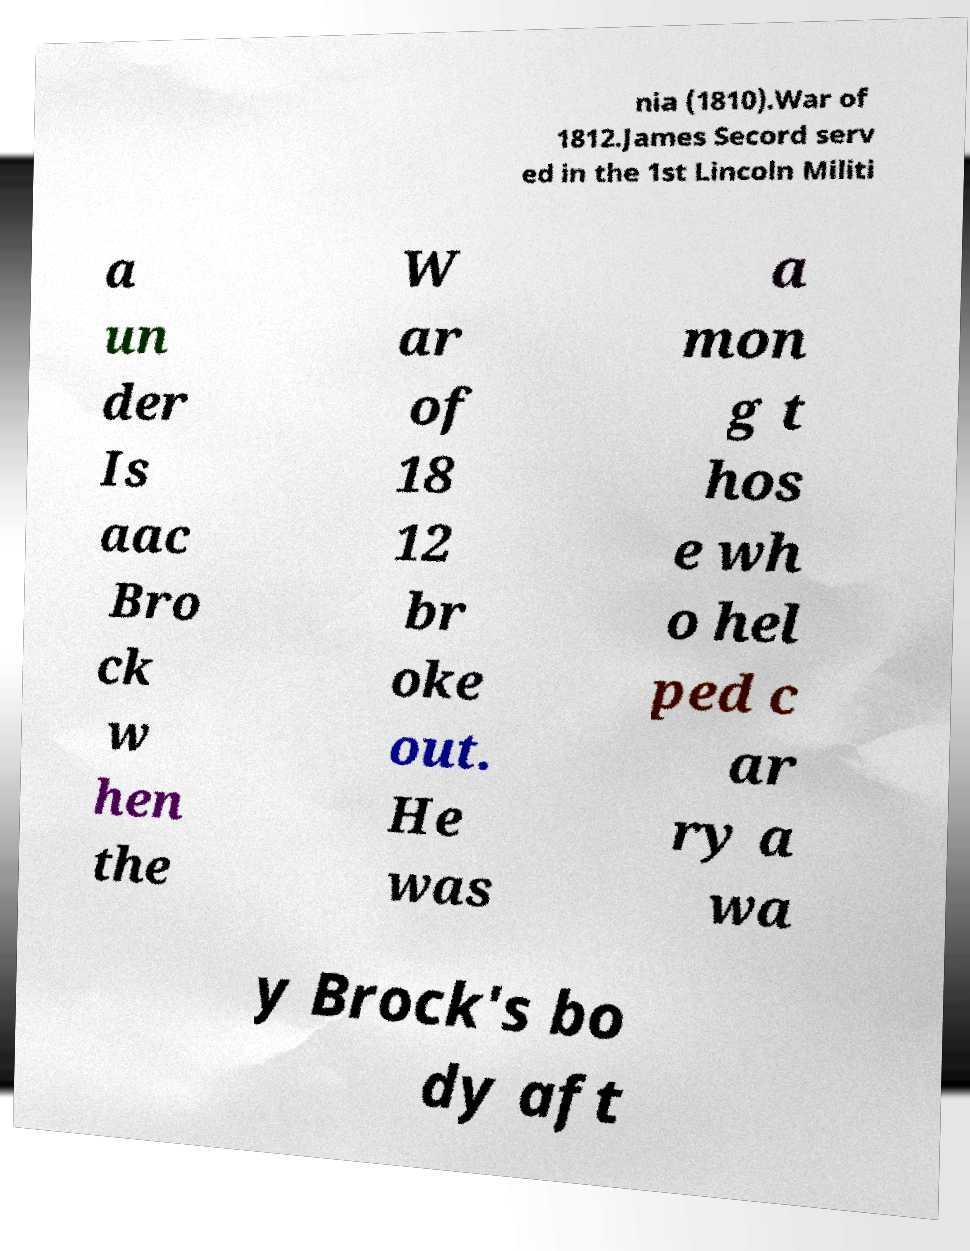Can you accurately transcribe the text from the provided image for me? nia (1810).War of 1812.James Secord serv ed in the 1st Lincoln Militi a un der Is aac Bro ck w hen the W ar of 18 12 br oke out. He was a mon g t hos e wh o hel ped c ar ry a wa y Brock's bo dy aft 